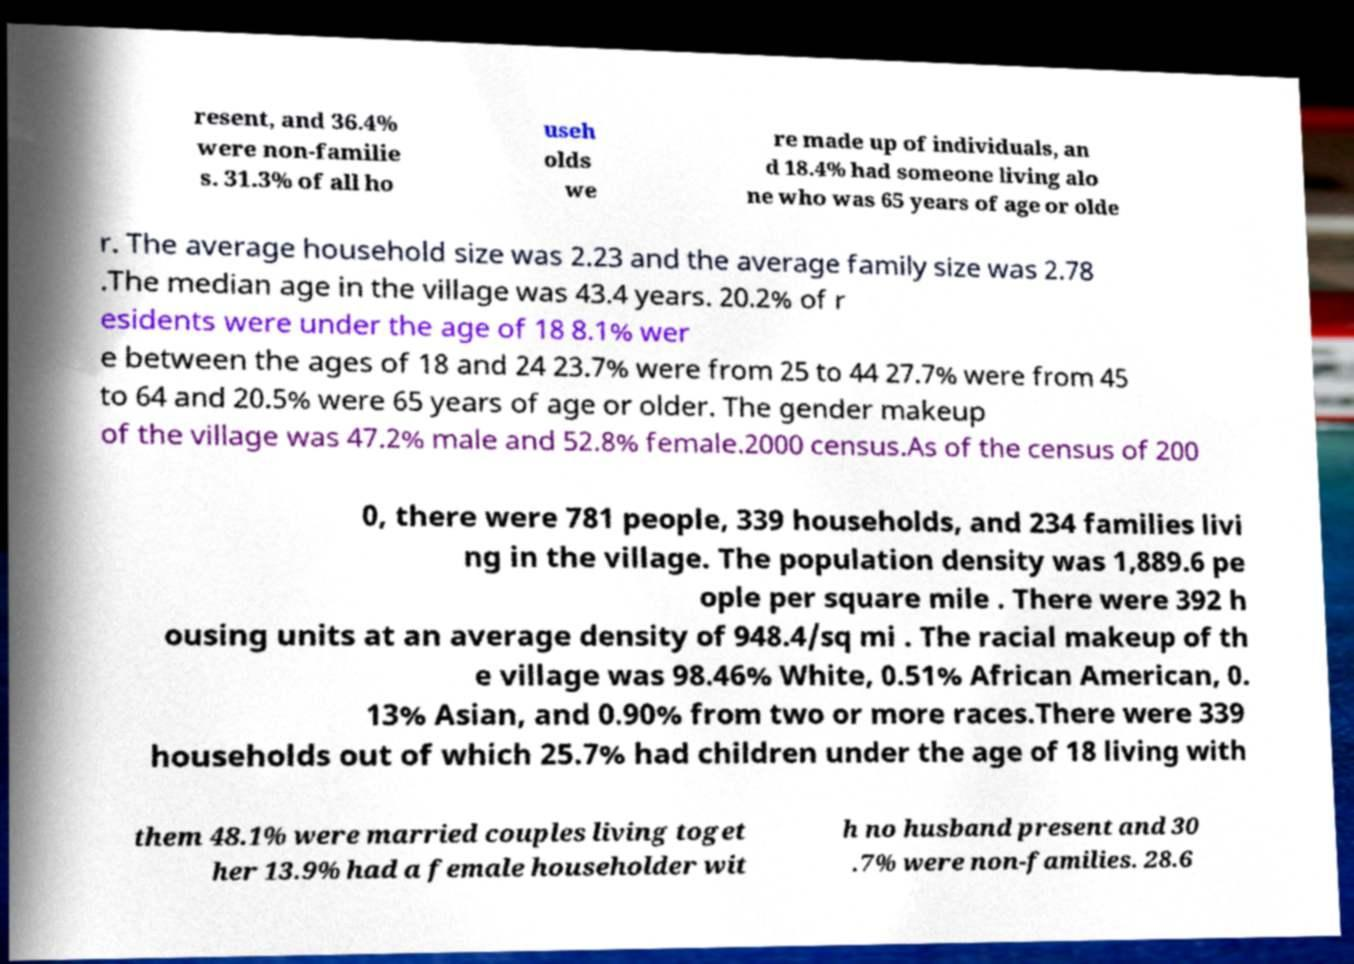I need the written content from this picture converted into text. Can you do that? resent, and 36.4% were non-familie s. 31.3% of all ho useh olds we re made up of individuals, an d 18.4% had someone living alo ne who was 65 years of age or olde r. The average household size was 2.23 and the average family size was 2.78 .The median age in the village was 43.4 years. 20.2% of r esidents were under the age of 18 8.1% wer e between the ages of 18 and 24 23.7% were from 25 to 44 27.7% were from 45 to 64 and 20.5% were 65 years of age or older. The gender makeup of the village was 47.2% male and 52.8% female.2000 census.As of the census of 200 0, there were 781 people, 339 households, and 234 families livi ng in the village. The population density was 1,889.6 pe ople per square mile . There were 392 h ousing units at an average density of 948.4/sq mi . The racial makeup of th e village was 98.46% White, 0.51% African American, 0. 13% Asian, and 0.90% from two or more races.There were 339 households out of which 25.7% had children under the age of 18 living with them 48.1% were married couples living toget her 13.9% had a female householder wit h no husband present and 30 .7% were non-families. 28.6 